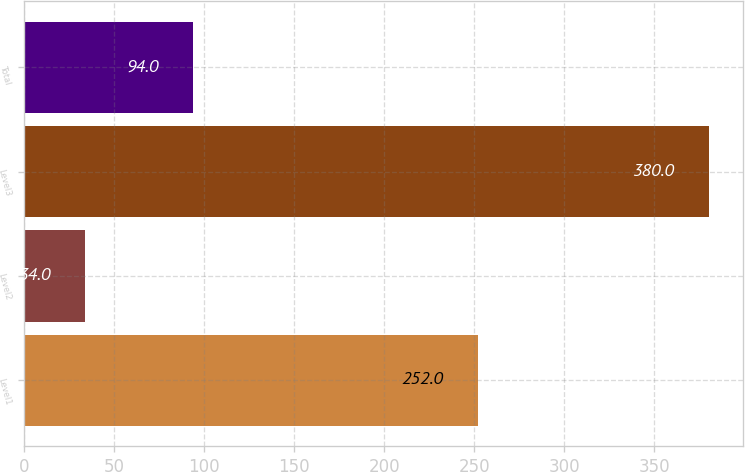Convert chart. <chart><loc_0><loc_0><loc_500><loc_500><bar_chart><fcel>Level1<fcel>Level2<fcel>Level3<fcel>Total<nl><fcel>252<fcel>34<fcel>380<fcel>94<nl></chart> 